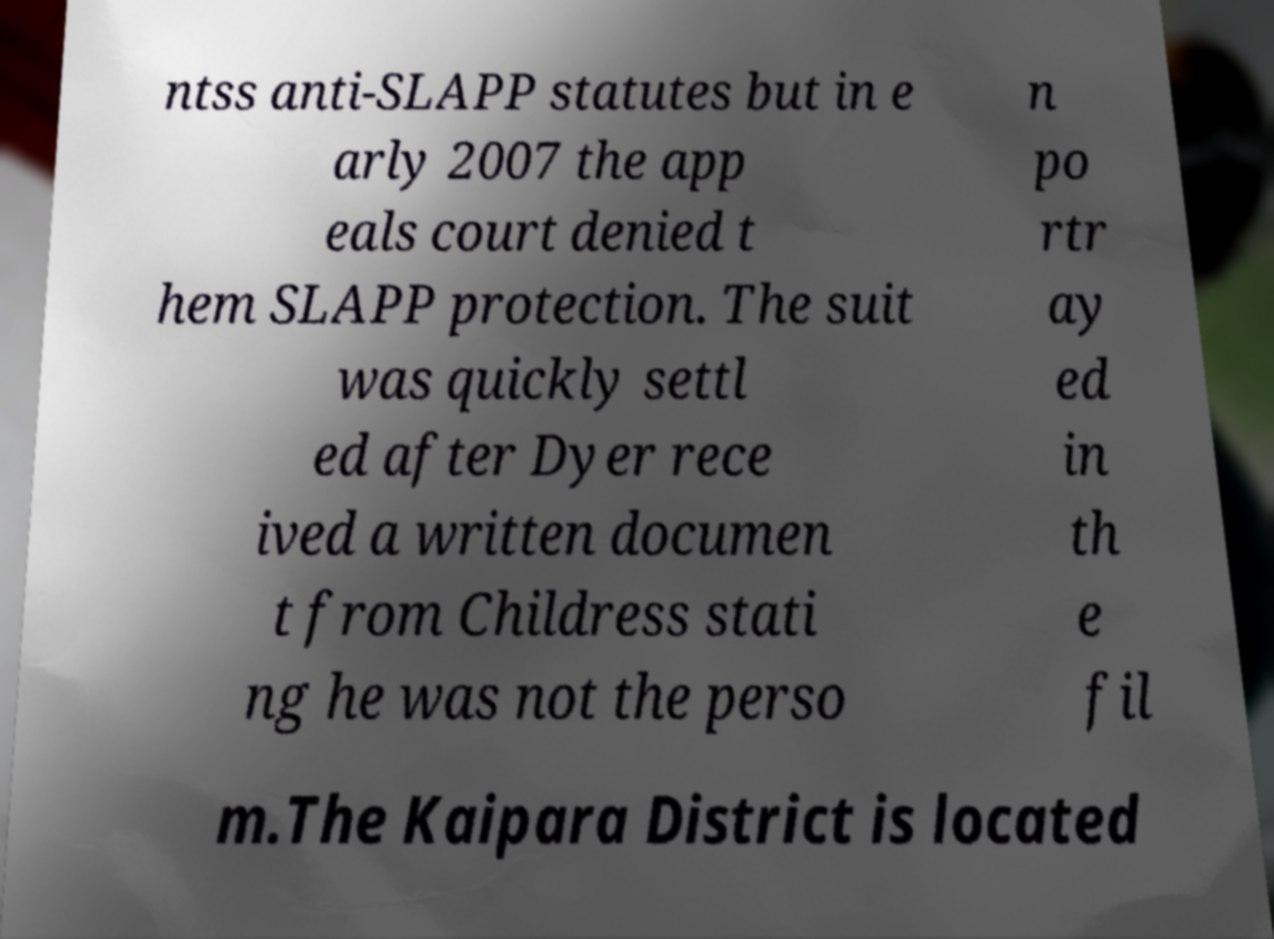There's text embedded in this image that I need extracted. Can you transcribe it verbatim? ntss anti-SLAPP statutes but in e arly 2007 the app eals court denied t hem SLAPP protection. The suit was quickly settl ed after Dyer rece ived a written documen t from Childress stati ng he was not the perso n po rtr ay ed in th e fil m.The Kaipara District is located 